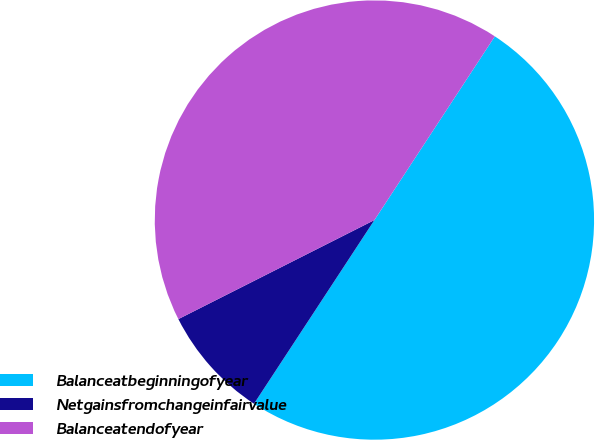<chart> <loc_0><loc_0><loc_500><loc_500><pie_chart><fcel>Balanceatbeginningofyear<fcel>Netgainsfromchangeinfairvalue<fcel>Balanceatendofyear<nl><fcel>50.0%<fcel>8.32%<fcel>41.68%<nl></chart> 